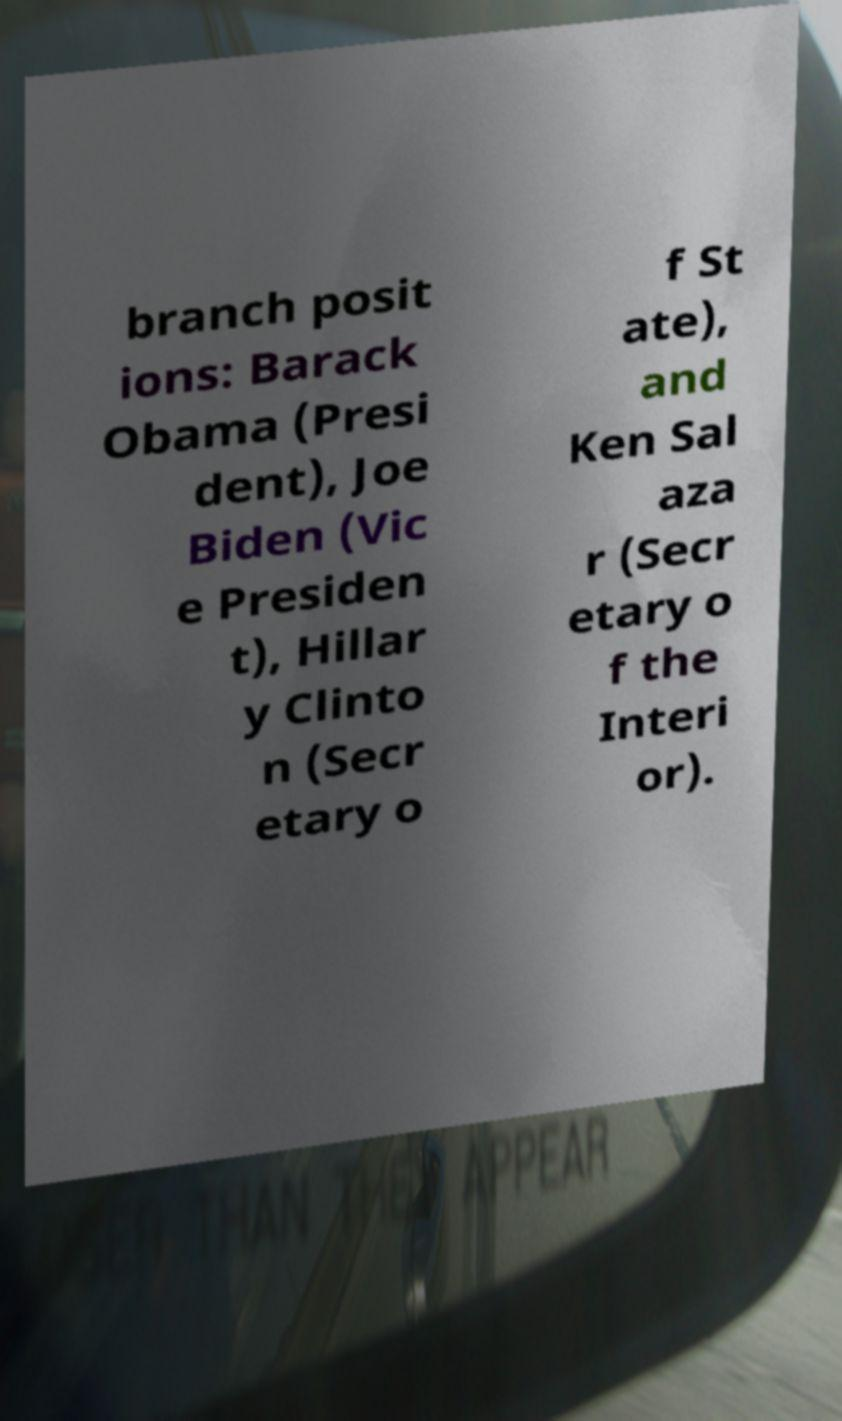Please read and relay the text visible in this image. What does it say? branch posit ions: Barack Obama (Presi dent), Joe Biden (Vic e Presiden t), Hillar y Clinto n (Secr etary o f St ate), and Ken Sal aza r (Secr etary o f the Interi or). 